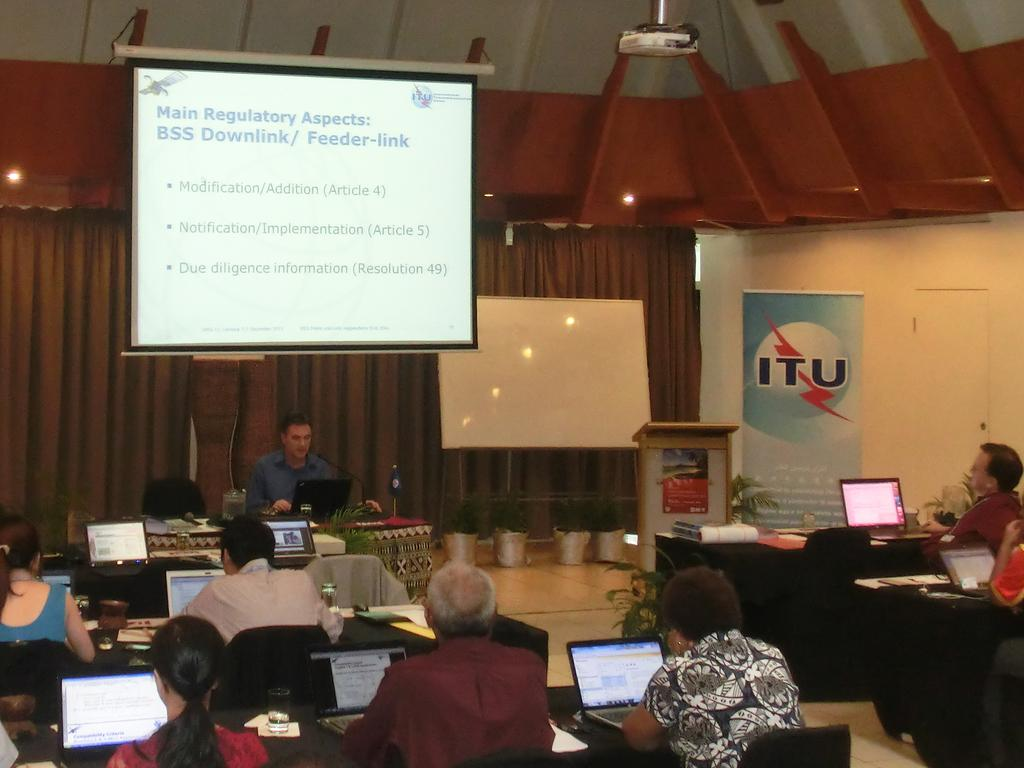<image>
Present a compact description of the photo's key features. Lecture attendees at ITU work on their laptops as a speaker addresses them. 